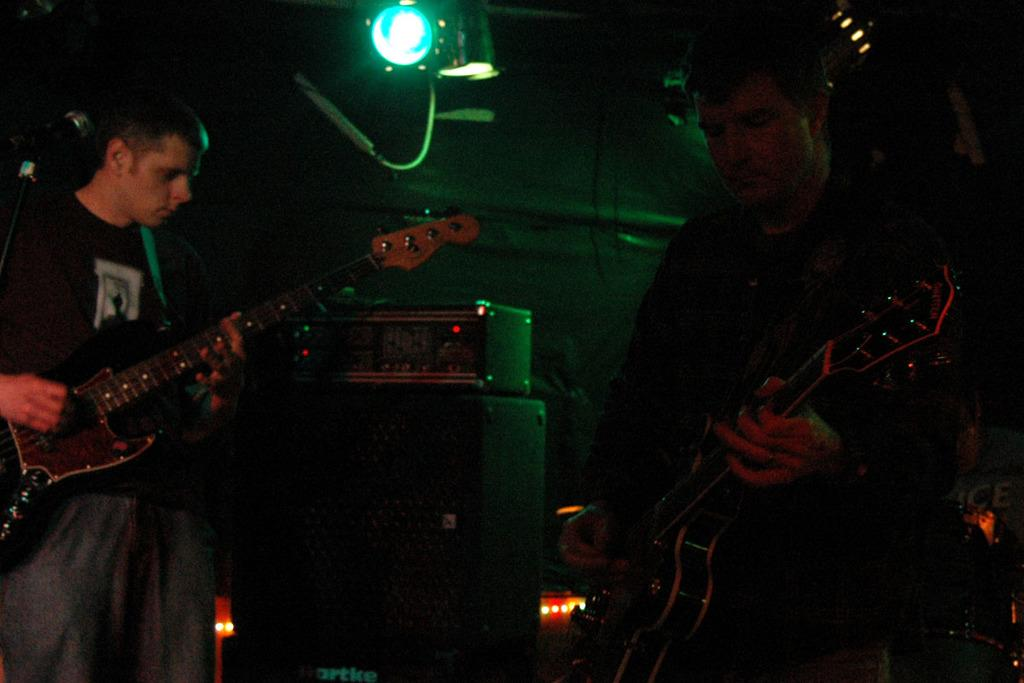What is the man on the right side of the image doing? The man on the right side of the image is playing a guitar. Can you describe the person on the left side of the image? The person on the left side of the image is also playing a guitar. How many people are present in the image? There are two people in the image. What type of yak can be seen in the image? There is no yak present in the image. How many beetles are crawling on the guitar strings in the image? There are no beetles present in the image. 